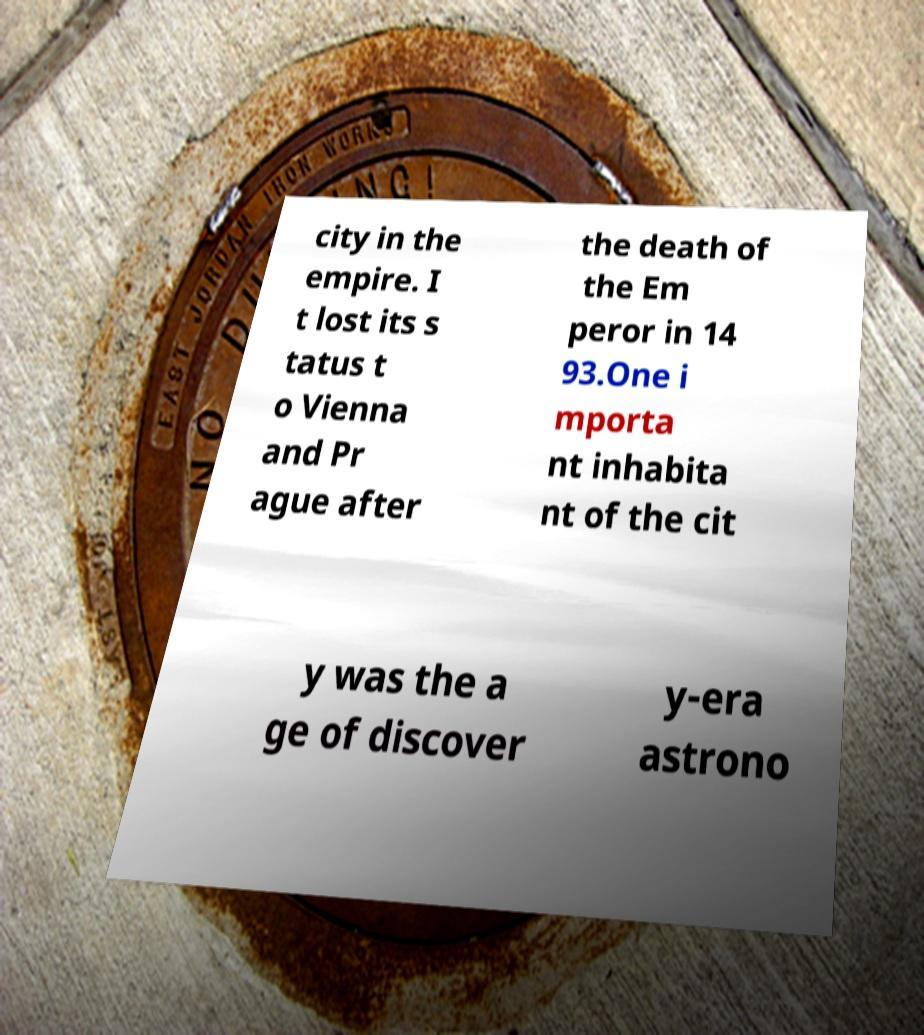Can you accurately transcribe the text from the provided image for me? city in the empire. I t lost its s tatus t o Vienna and Pr ague after the death of the Em peror in 14 93.One i mporta nt inhabita nt of the cit y was the a ge of discover y-era astrono 